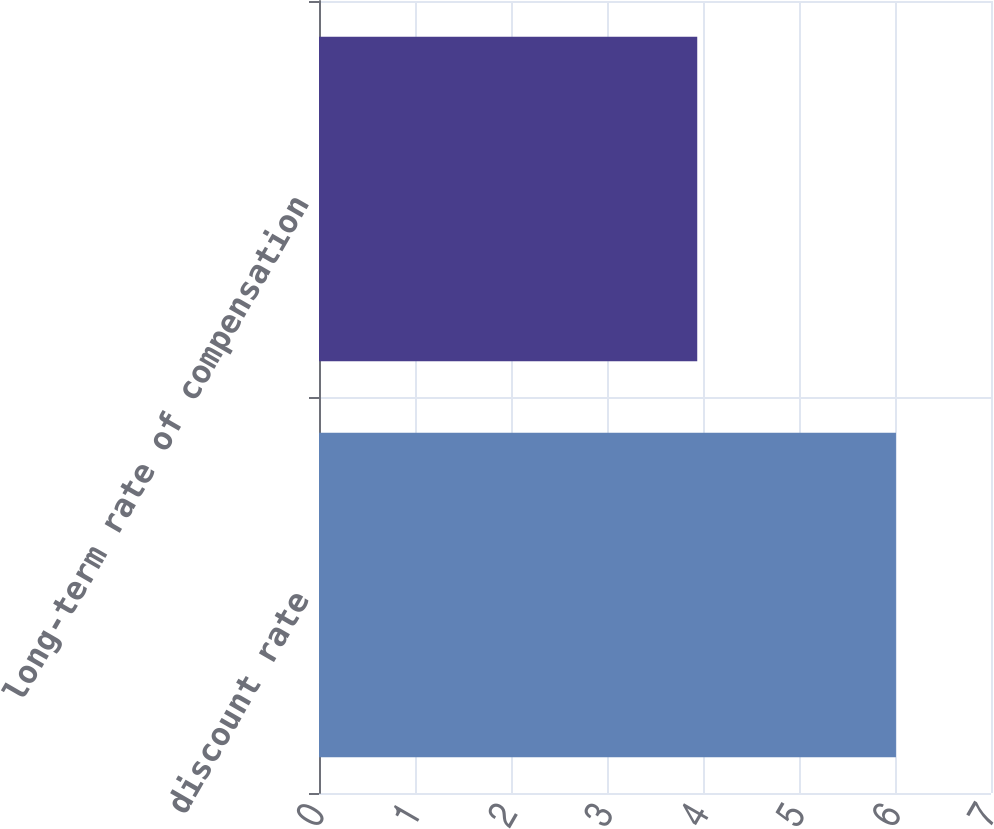<chart> <loc_0><loc_0><loc_500><loc_500><bar_chart><fcel>discount rate<fcel>long-term rate of compensation<nl><fcel>6.01<fcel>3.94<nl></chart> 